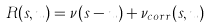<formula> <loc_0><loc_0><loc_500><loc_500>R ( s , u ) = \nu ( s - u ) + \nu _ { c o r r } ( s , u )</formula> 